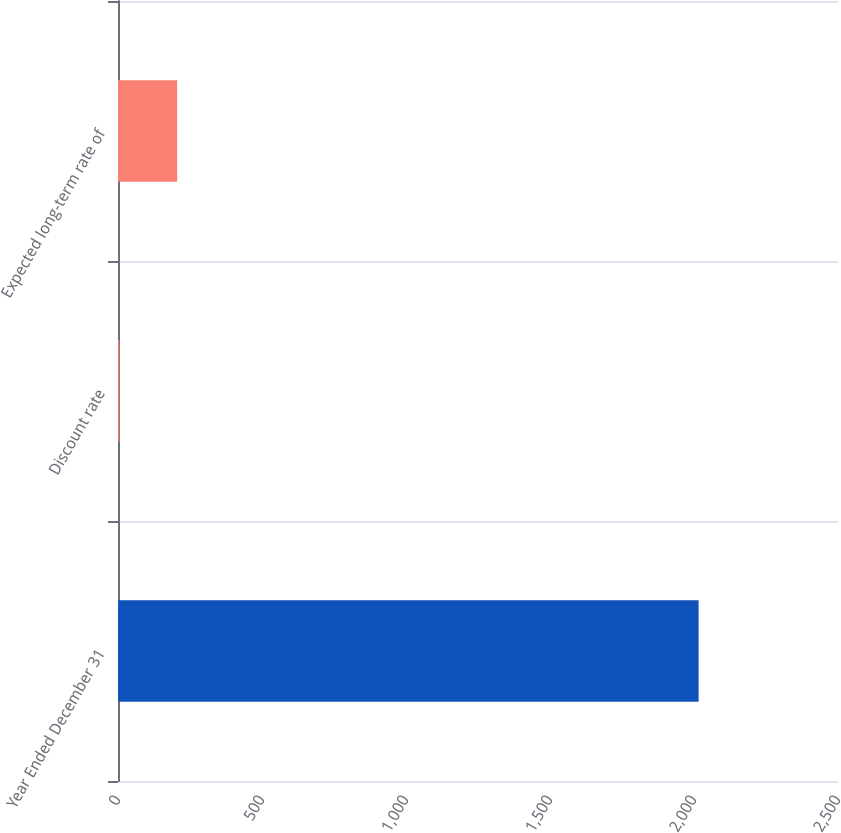<chart> <loc_0><loc_0><loc_500><loc_500><bar_chart><fcel>Year Ended December 31<fcel>Discount rate<fcel>Expected long-term rate of<nl><fcel>2016<fcel>4.25<fcel>205.43<nl></chart> 